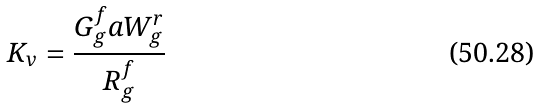Convert formula to latex. <formula><loc_0><loc_0><loc_500><loc_500>K _ { v } = \frac { G _ { g } ^ { f } a W _ { g } ^ { r } } { R _ { g } ^ { f } }</formula> 